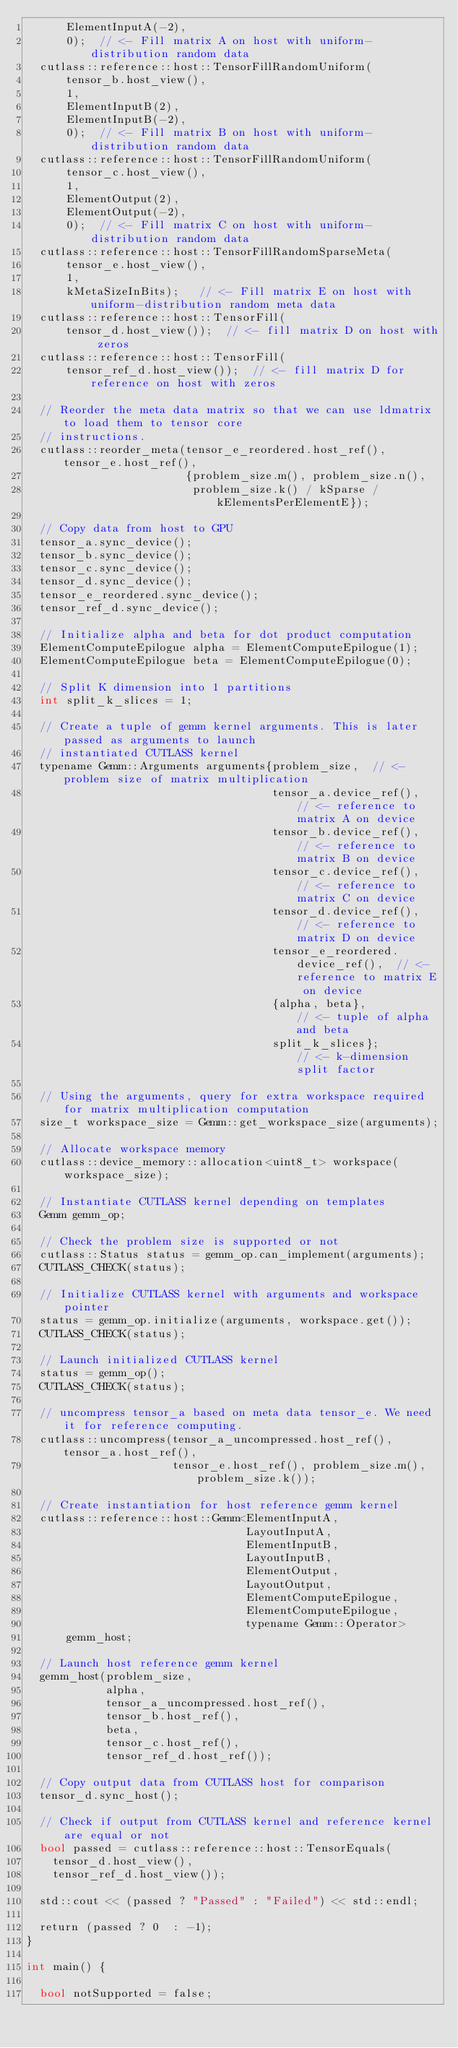Convert code to text. <code><loc_0><loc_0><loc_500><loc_500><_Cuda_>      ElementInputA(-2),
      0);  // <- Fill matrix A on host with uniform-distribution random data
  cutlass::reference::host::TensorFillRandomUniform(
      tensor_b.host_view(),
      1,
      ElementInputB(2),
      ElementInputB(-2),
      0);  // <- Fill matrix B on host with uniform-distribution random data
  cutlass::reference::host::TensorFillRandomUniform(
      tensor_c.host_view(),
      1,
      ElementOutput(2),
      ElementOutput(-2),
      0);  // <- Fill matrix C on host with uniform-distribution random data
  cutlass::reference::host::TensorFillRandomSparseMeta(                                           
      tensor_e.host_view(),
      1,
      kMetaSizeInBits);   // <- Fill matrix E on host with uniform-distribution random meta data
  cutlass::reference::host::TensorFill(
      tensor_d.host_view());  // <- fill matrix D on host with zeros
  cutlass::reference::host::TensorFill(
      tensor_ref_d.host_view());  // <- fill matrix D for reference on host with zeros

  // Reorder the meta data matrix so that we can use ldmatrix to load them to tensor core
  // instructions.
  cutlass::reorder_meta(tensor_e_reordered.host_ref(), tensor_e.host_ref(),                         
                        {problem_size.m(), problem_size.n(),                                        
                         problem_size.k() / kSparse / kElementsPerElementE});

  // Copy data from host to GPU
  tensor_a.sync_device();
  tensor_b.sync_device();
  tensor_c.sync_device();
  tensor_d.sync_device();
  tensor_e_reordered.sync_device();
  tensor_ref_d.sync_device();

  // Initialize alpha and beta for dot product computation
  ElementComputeEpilogue alpha = ElementComputeEpilogue(1);
  ElementComputeEpilogue beta = ElementComputeEpilogue(0);

  // Split K dimension into 1 partitions
  int split_k_slices = 1;

  // Create a tuple of gemm kernel arguments. This is later passed as arguments to launch
  // instantiated CUTLASS kernel
  typename Gemm::Arguments arguments{problem_size,  // <- problem size of matrix multiplication
                                     tensor_a.device_ref(),  // <- reference to matrix A on device
                                     tensor_b.device_ref(),  // <- reference to matrix B on device
                                     tensor_c.device_ref(),  // <- reference to matrix C on device
                                     tensor_d.device_ref(),  // <- reference to matrix D on device
                                     tensor_e_reordered.device_ref(),  // <- reference to matrix E on device
                                     {alpha, beta},          // <- tuple of alpha and beta
                                     split_k_slices};        // <- k-dimension split factor

  // Using the arguments, query for extra workspace required for matrix multiplication computation
  size_t workspace_size = Gemm::get_workspace_size(arguments);

  // Allocate workspace memory
  cutlass::device_memory::allocation<uint8_t> workspace(workspace_size);

  // Instantiate CUTLASS kernel depending on templates
  Gemm gemm_op;

  // Check the problem size is supported or not 
  cutlass::Status status = gemm_op.can_implement(arguments);
  CUTLASS_CHECK(status);

  // Initialize CUTLASS kernel with arguments and workspace pointer
  status = gemm_op.initialize(arguments, workspace.get());
  CUTLASS_CHECK(status);

  // Launch initialized CUTLASS kernel
  status = gemm_op();
  CUTLASS_CHECK(status);

  // uncompress tensor_a based on meta data tensor_e. We need it for reference computing.
  cutlass::uncompress(tensor_a_uncompressed.host_ref(), tensor_a.host_ref(),
                      tensor_e.host_ref(), problem_size.m(), problem_size.k());
 
  // Create instantiation for host reference gemm kernel
  cutlass::reference::host::Gemm<ElementInputA,
                                 LayoutInputA,
                                 ElementInputB,
                                 LayoutInputB,
                                 ElementOutput,
                                 LayoutOutput,
                                 ElementComputeEpilogue,
                                 ElementComputeEpilogue,
                                 typename Gemm::Operator>
      gemm_host;

  // Launch host reference gemm kernel
  gemm_host(problem_size,
            alpha,
            tensor_a_uncompressed.host_ref(),
            tensor_b.host_ref(),
            beta,
            tensor_c.host_ref(),
            tensor_ref_d.host_ref());

  // Copy output data from CUTLASS host for comparison
  tensor_d.sync_host();

  // Check if output from CUTLASS kernel and reference kernel are equal or not
  bool passed = cutlass::reference::host::TensorEquals(
    tensor_d.host_view(),
    tensor_ref_d.host_view());

  std::cout << (passed ? "Passed" : "Failed") << std::endl;

  return (passed ? 0  : -1);
}

int main() {
  
  bool notSupported = false;
</code> 